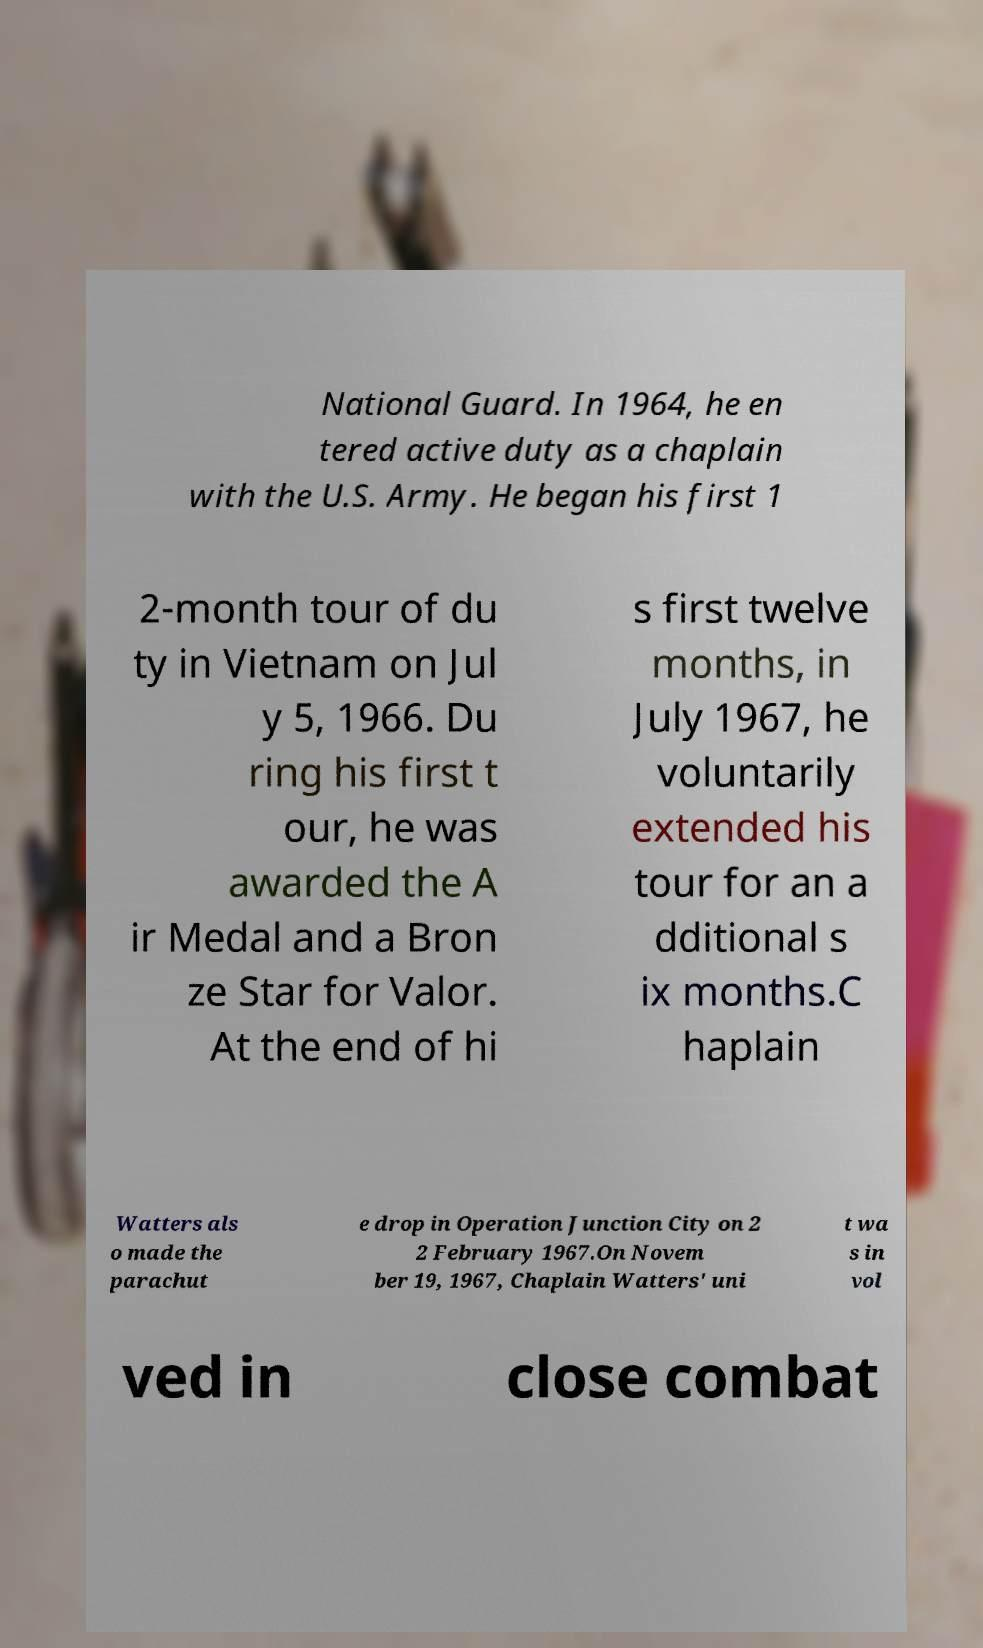Please identify and transcribe the text found in this image. National Guard. In 1964, he en tered active duty as a chaplain with the U.S. Army. He began his first 1 2-month tour of du ty in Vietnam on Jul y 5, 1966. Du ring his first t our, he was awarded the A ir Medal and a Bron ze Star for Valor. At the end of hi s first twelve months, in July 1967, he voluntarily extended his tour for an a dditional s ix months.C haplain Watters als o made the parachut e drop in Operation Junction City on 2 2 February 1967.On Novem ber 19, 1967, Chaplain Watters' uni t wa s in vol ved in close combat 